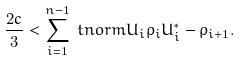Convert formula to latex. <formula><loc_0><loc_0><loc_500><loc_500>\frac { 2 c } { 3 } & < \sum _ { i = 1 } ^ { n - 1 } \ t n o r m { U _ { i } \rho _ { i } U _ { i } ^ { * } - \rho _ { i + 1 } } .</formula> 